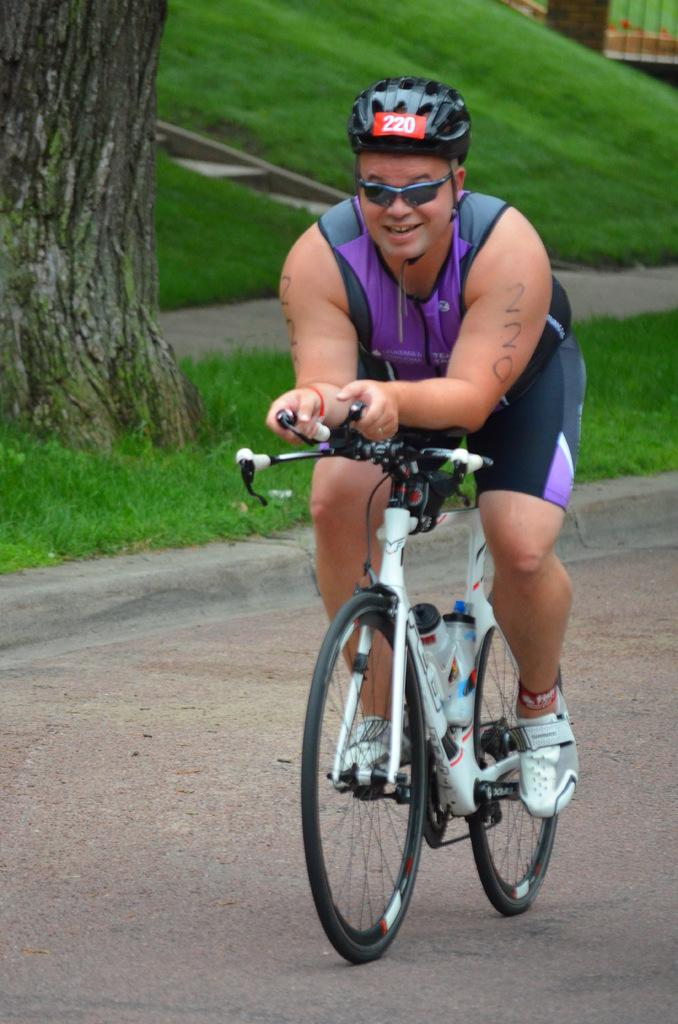What is the man in the image doing? The man is riding a bicycle in the image. What safety equipment is the man wearing? The man is wearing a helmet and goggles in the image. What is the man's facial expression? The man is smiling in the image. What can be seen in the background of the image? There is grass, a tree, and a fence in the background of the image. How many icicles are hanging from the tree in the image? There are no icicles present in the image, as it is set in a grassy area with a tree and a fence. 